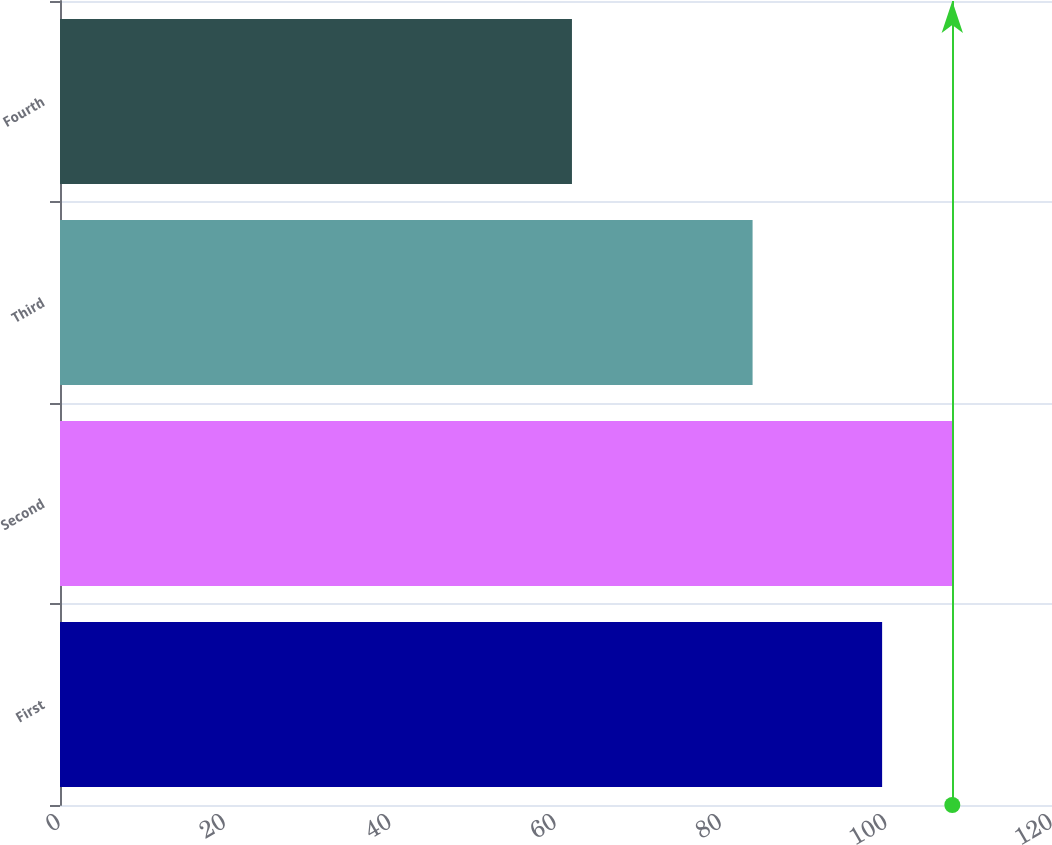<chart> <loc_0><loc_0><loc_500><loc_500><bar_chart><fcel>First<fcel>Second<fcel>Third<fcel>Fourth<nl><fcel>99.45<fcel>107.94<fcel>83.78<fcel>61.93<nl></chart> 